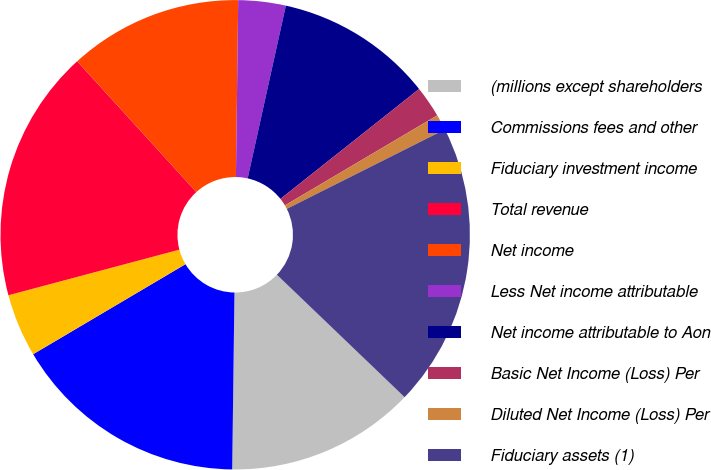Convert chart to OTSL. <chart><loc_0><loc_0><loc_500><loc_500><pie_chart><fcel>(millions except shareholders<fcel>Commissions fees and other<fcel>Fiduciary investment income<fcel>Total revenue<fcel>Net income<fcel>Less Net income attributable<fcel>Net income attributable to Aon<fcel>Basic Net Income (Loss) Per<fcel>Diluted Net Income (Loss) Per<fcel>Fiduciary assets (1)<nl><fcel>13.04%<fcel>16.3%<fcel>4.35%<fcel>17.39%<fcel>11.96%<fcel>3.26%<fcel>10.87%<fcel>2.17%<fcel>1.09%<fcel>19.57%<nl></chart> 